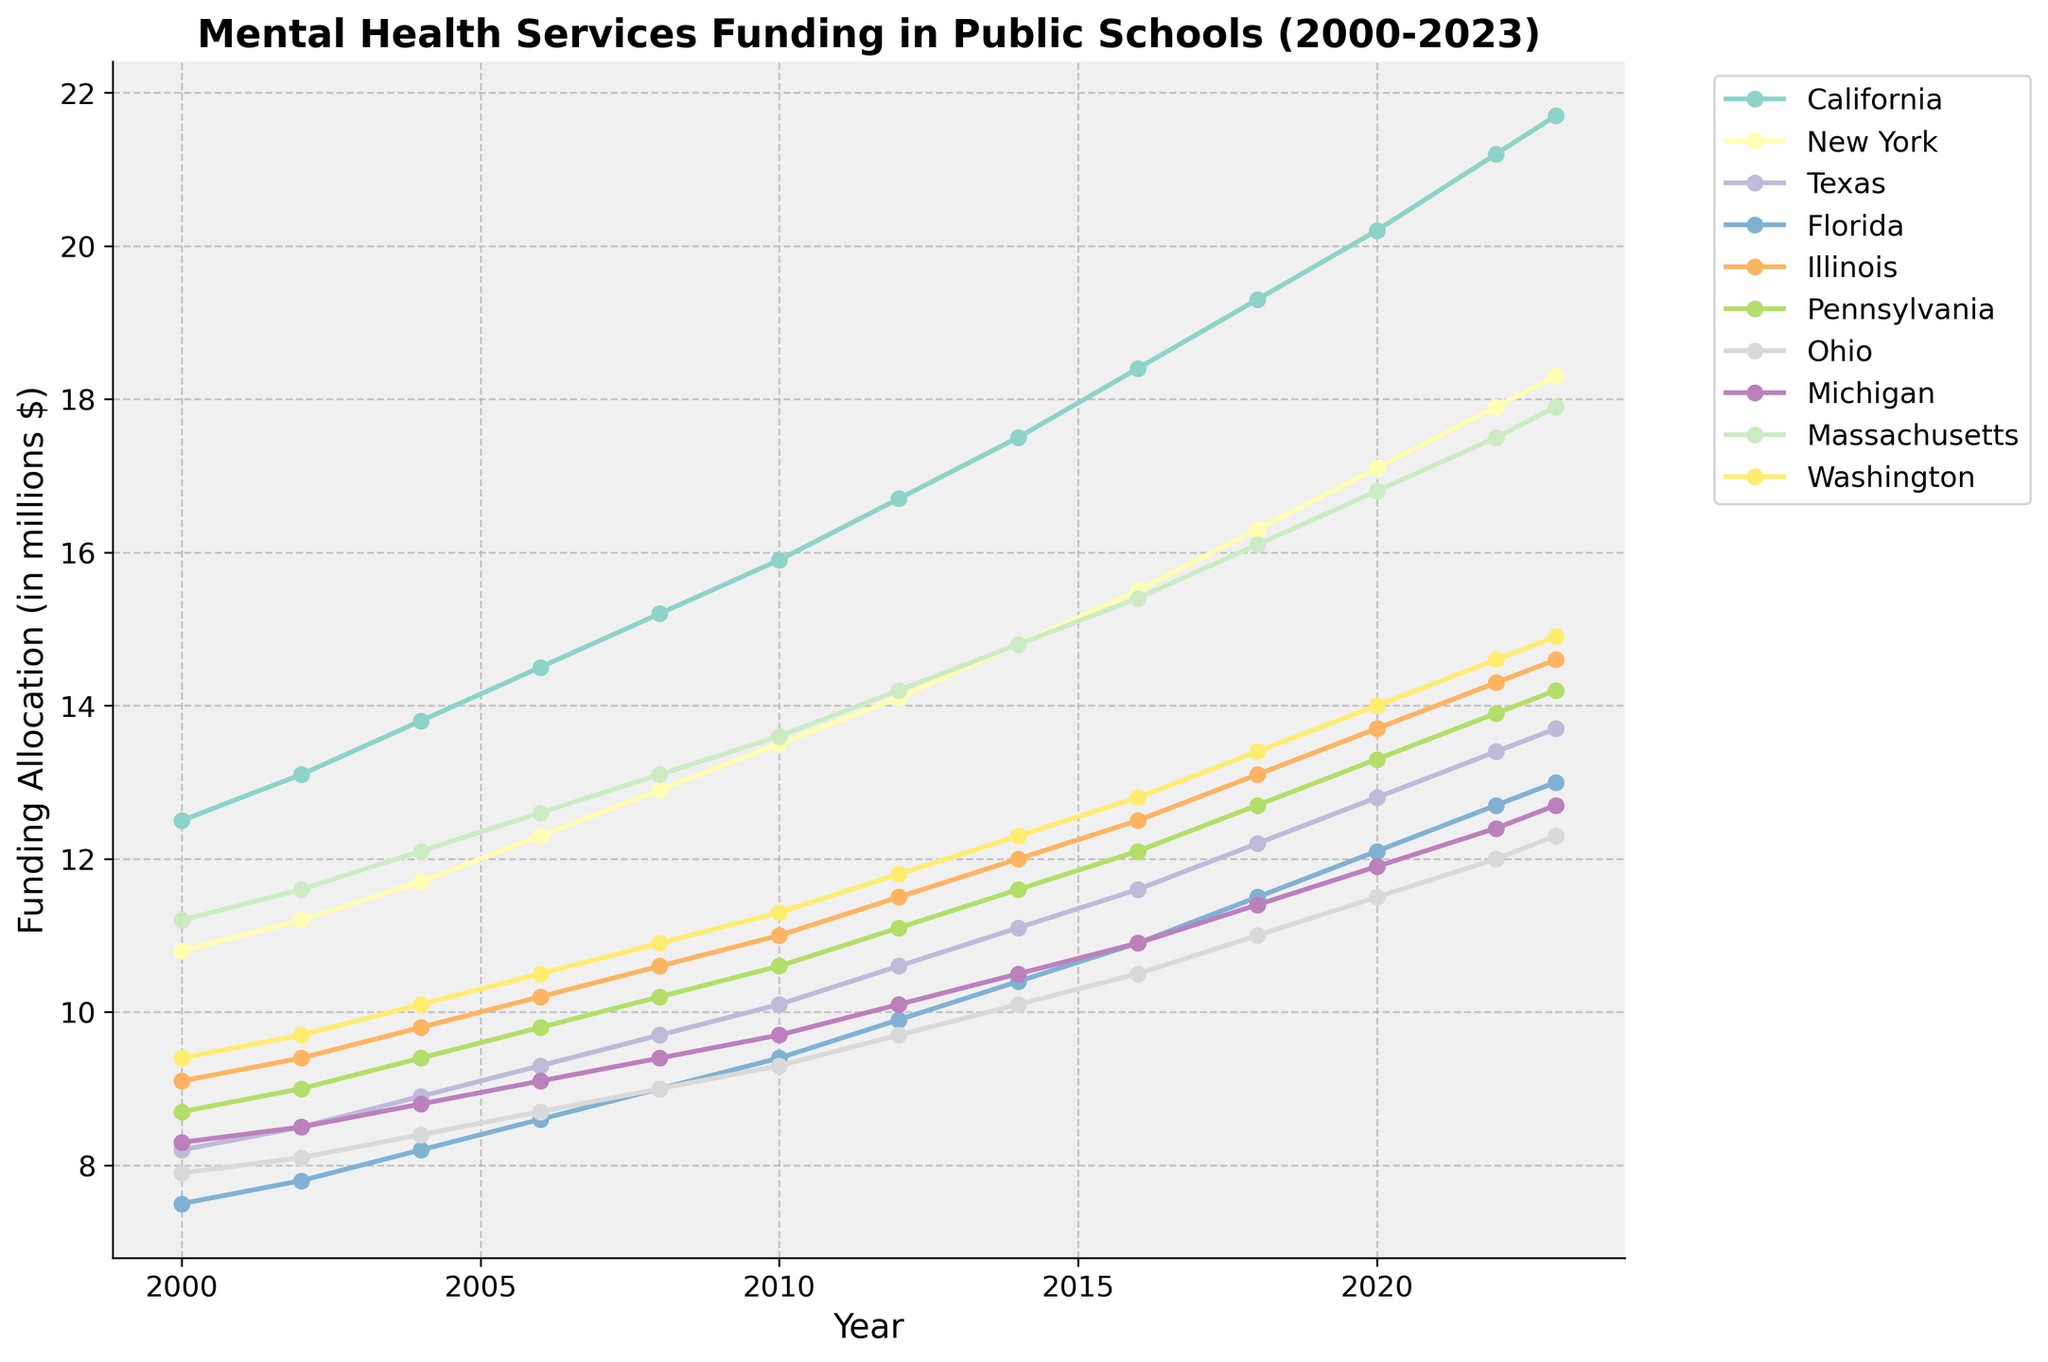How does the funding allocation for mental health services in California compare to New York in 2023? Looking at the endpoints of the lines for California and New York in 2023, California is slightly higher with 21.7 million dollars compared to New York's 18.3 million dollars.
Answer: California has higher funding in 2023 Which state had the highest increase in funding allocation from 2000 to 2023? To find this, look at the funding allocations in 2000 and 2023 and calculate the difference for each state. California increased from 12.5 to 21.7 (a difference of 9.2), New York from 10.8 to 18.3 (7.5), and so on. California has the largest difference.
Answer: California Which states show a consistent upward trend in funding throughout the entire period? Identify states whose funding lines steadily increase without any drops from 2000 to 2023. California, New York, Massachusetts, and Washington exhibit a consistent upward trend.
Answer: California, New York, Massachusetts, Washington What is the average funding in 2023 across all states? Add the funding allocations for all the states in 2023 and divide by the number of states: (21.7 + 18.3 + 13.7 + 13 + 14.6 + 14.2 + 12.3 + 12.7 + 17.9 + 14.9) / 10.
Answer: 15.33 million dollars By how much did the funding for Florida increase from 2000 to 2023? Subtract the funding allocation of Florida in 2000 from its value in 2023: 13.0 - 7.5 = 5.5 million dollars.
Answer: 5.5 million dollars Which state had the smallest increase in funding between 2000 and 2023? Compute the difference in funding for each state from the year 2000 to 2023. Ohio increased the least from 7.9 to 12.3 (a change of 4.4 million dollars).
Answer: Ohio What is the total funding for mental health services across all states in 2010? Sum the funding allocations for all states in 2010: 15.9 + 13.5 + 10.1 + 9.4 + 11.0 + 10.6 + 9.3 + 9.7 + 13.6 + 11.3.
Answer: 114.4 million dollars Compare the funding trends for Illinois and Pennsylvania from 2000 to 2023. Both states show an upward trend. Illinois started at 9.1 in 2000 and reached 14.6 in 2023, while Pennsylvania started at 8.7 and reached 14.2 in the same period. Even though Pennsylvania had a lower start, both states reached close values at the end.
Answer: Both have upward trends, Illinois has slightly higher funding 